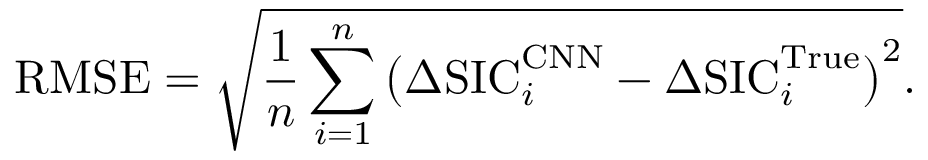<formula> <loc_0><loc_0><loc_500><loc_500>R M S E = \sqrt { \frac { 1 } { n } \sum _ { i = 1 } ^ { n } \left ( \Delta S I C _ { i } ^ { C N N } - \Delta S I C _ { i } ^ { T r u e } \right ) ^ { 2 } } .</formula> 